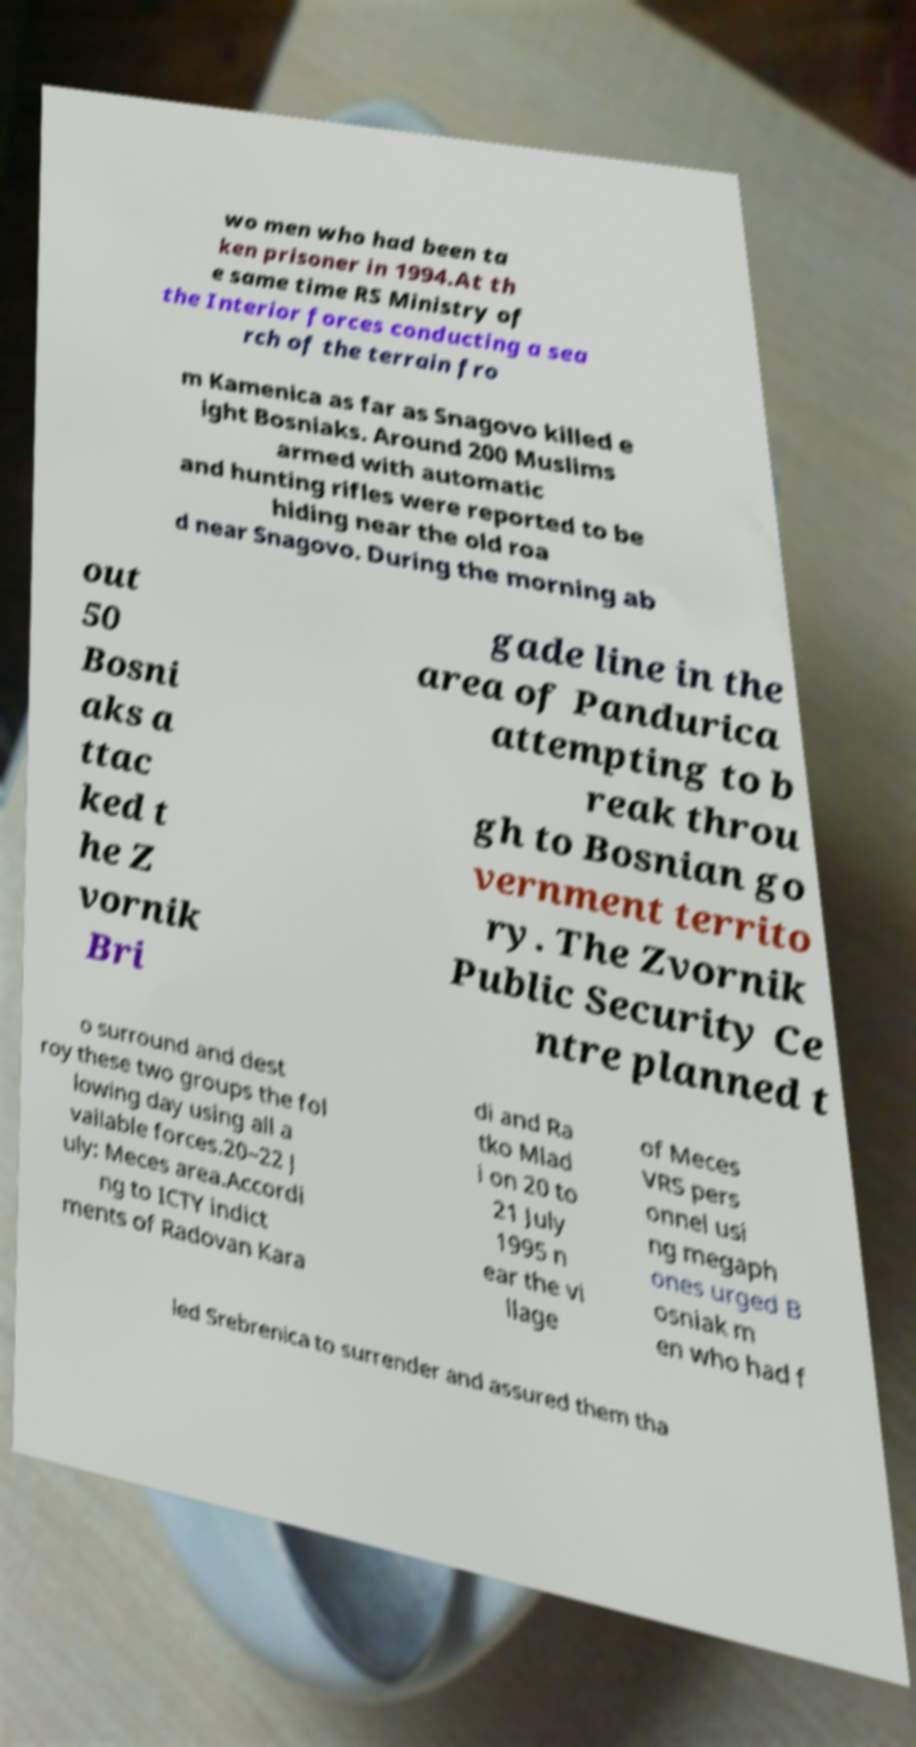What messages or text are displayed in this image? I need them in a readable, typed format. wo men who had been ta ken prisoner in 1994.At th e same time RS Ministry of the Interior forces conducting a sea rch of the terrain fro m Kamenica as far as Snagovo killed e ight Bosniaks. Around 200 Muslims armed with automatic and hunting rifles were reported to be hiding near the old roa d near Snagovo. During the morning ab out 50 Bosni aks a ttac ked t he Z vornik Bri gade line in the area of Pandurica attempting to b reak throu gh to Bosnian go vernment territo ry. The Zvornik Public Security Ce ntre planned t o surround and dest roy these two groups the fol lowing day using all a vailable forces.20–22 J uly: Meces area.Accordi ng to ICTY indict ments of Radovan Kara di and Ra tko Mlad i on 20 to 21 July 1995 n ear the vi llage of Meces VRS pers onnel usi ng megaph ones urged B osniak m en who had f led Srebrenica to surrender and assured them tha 